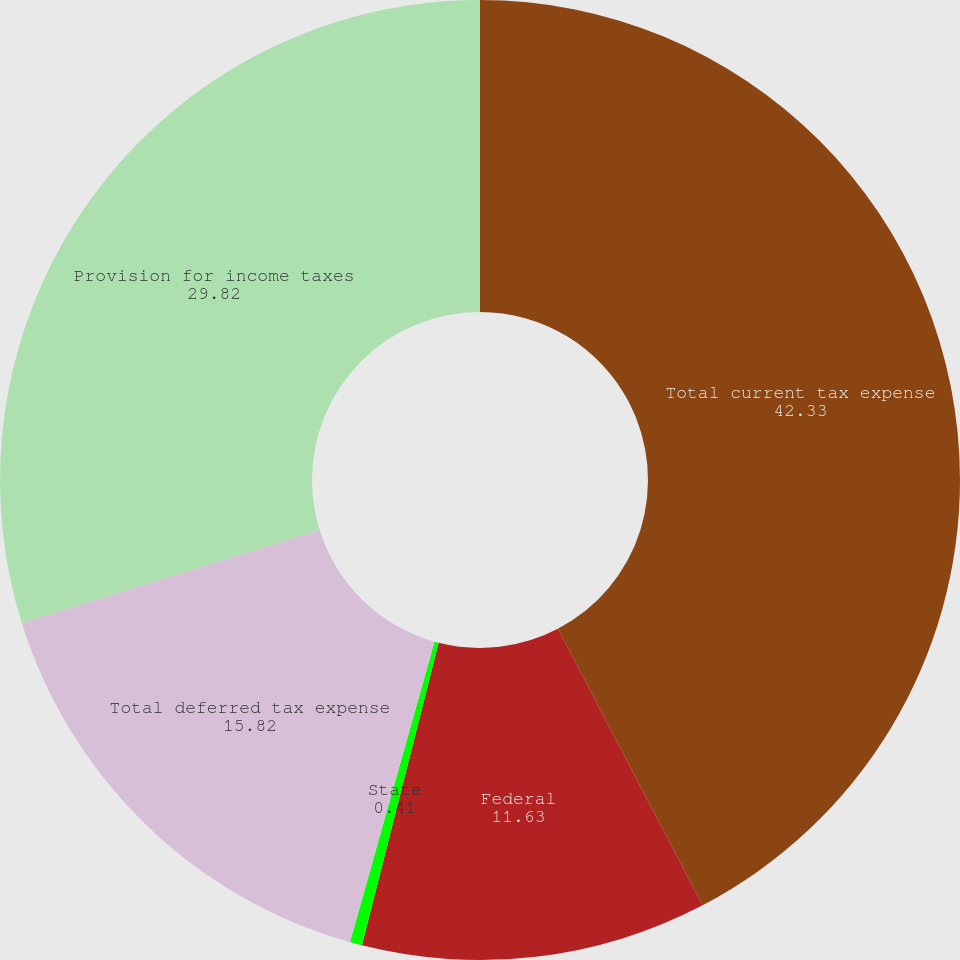Convert chart. <chart><loc_0><loc_0><loc_500><loc_500><pie_chart><fcel>Total current tax expense<fcel>Federal<fcel>State<fcel>Total deferred tax expense<fcel>Provision for income taxes<nl><fcel>42.33%<fcel>11.63%<fcel>0.41%<fcel>15.82%<fcel>29.82%<nl></chart> 